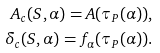<formula> <loc_0><loc_0><loc_500><loc_500>A _ { c } ( S , \alpha ) = A ( \tau _ { P } ( \alpha ) ) , \\ \delta _ { c } ( S , \alpha ) = f _ { \alpha } ( \tau _ { P } ( \alpha ) ) .</formula> 